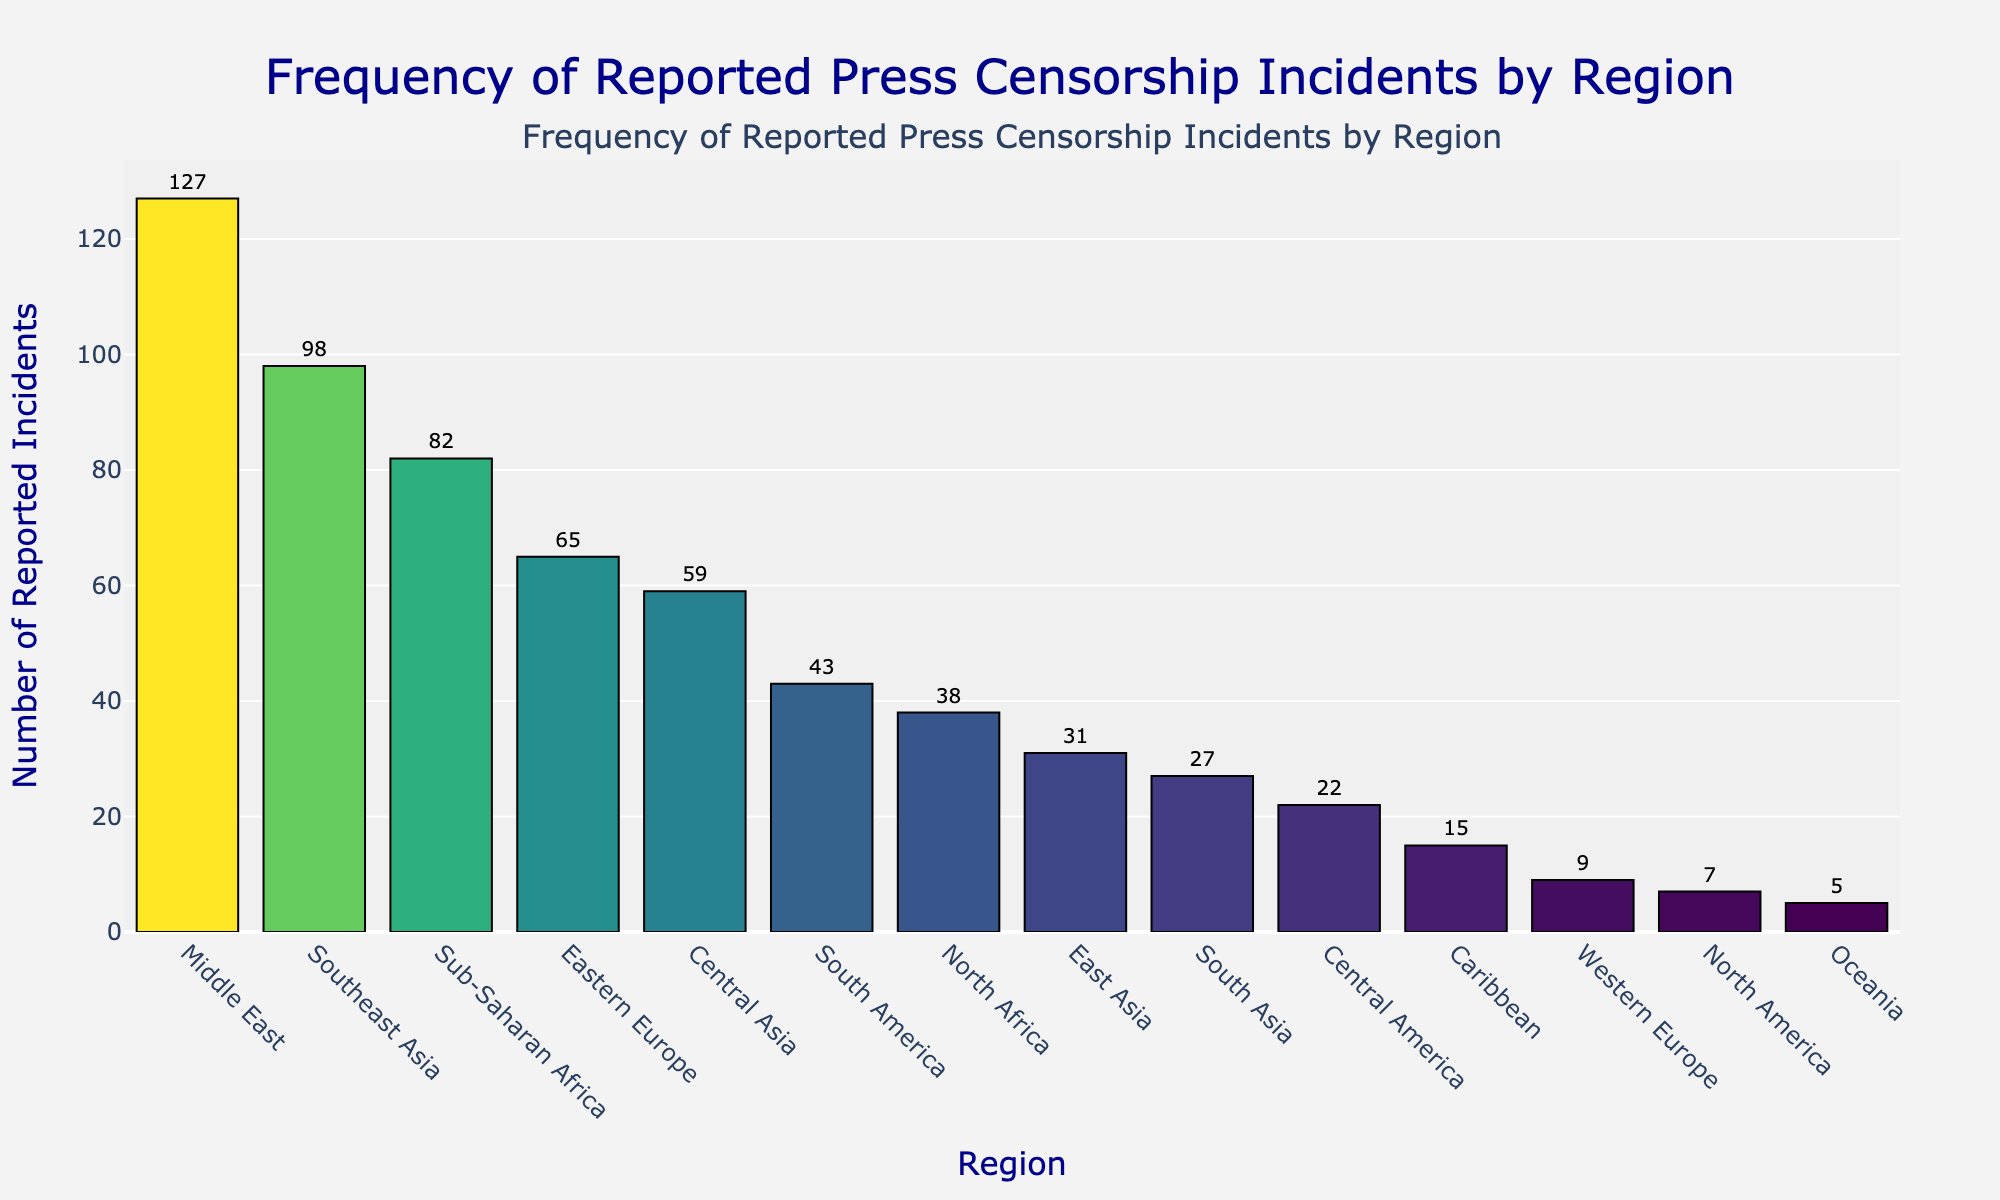Which region has the highest number of reported press censorship incidents? Looking at the bar chart, the Middle East region has the tallest bar, indicating it has the highest number of reported incidents.
Answer: Middle East What is the total number of reported press censorship incidents in the top three regions combined? The three regions with the highest number of incidents are the Middle East (127), Southeast Asia (98), and Sub-Saharan Africa (82). Adding these numbers together: 127 + 98 + 82 = 307.
Answer: 307 Which regions have fewer than 10 reported press censorship incidents? By examining the bars that are very short, Western Europe (9), North America (7), and Oceania (5) all have fewer than 10 incidents.
Answer: Western Europe, North America, Oceania How many more reported incidents are there in Eastern Europe compared to South America? Eastern Europe has 65 incidents and South America has 43 incidents. The difference is calculated as 65 - 43.
Answer: 22 What is the average number of reported incidents in North Africa, East Asia, and South Asia? North Africa has 38 incidents, East Asia has 31, and South Asia has 27. Their total is 38 + 31 + 27 = 96. There are three regions, so the average is 96 / 3.
Answer: 32 Does Central America have more reported incidents than the Caribbean? Central America has 22 incidents, while the Caribbean has 15. Since 22 is greater than 15, Central America has more reported incidents.
Answer: Yes 